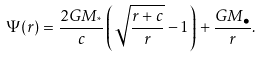Convert formula to latex. <formula><loc_0><loc_0><loc_500><loc_500>\Psi ( r ) = \frac { 2 G M _ { ^ { * } } } { c } \left ( \sqrt { \frac { r + c } { r } } - 1 \right ) + \frac { G M _ { \bullet } } { r } .</formula> 